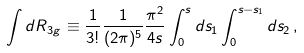<formula> <loc_0><loc_0><loc_500><loc_500>\int d R _ { 3 g } \equiv \frac { 1 } { 3 ! } \frac { 1 } { ( 2 \pi ) ^ { 5 } } \frac { \pi ^ { 2 } } { 4 s } \int _ { 0 } ^ { s } d s _ { 1 } \int _ { 0 } ^ { s - s _ { 1 } } d s _ { 2 } \, ,</formula> 